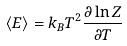Convert formula to latex. <formula><loc_0><loc_0><loc_500><loc_500>\langle E \rangle = k _ { B } T ^ { 2 } \frac { \partial \ln Z } { \partial T }</formula> 